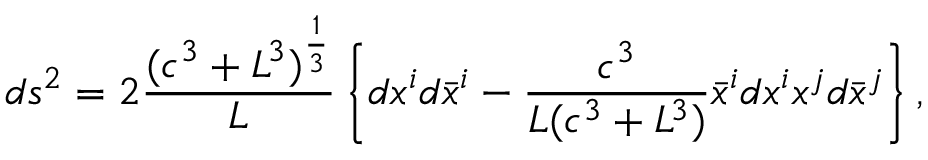<formula> <loc_0><loc_0><loc_500><loc_500>d s ^ { 2 } = 2 \frac { ( c ^ { 3 } + L ^ { 3 } ) ^ { \frac { 1 } { 3 } } } L \left \{ d x ^ { i } d \bar { x } ^ { i } - \frac { c ^ { 3 } } { L ( c ^ { 3 } + L ^ { 3 } ) } \bar { x } ^ { i } d x ^ { i } x ^ { j } d \bar { x } ^ { j } \right \} ,</formula> 